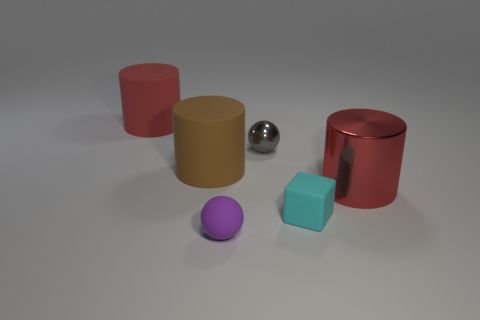There is a metallic thing that is to the right of the cyan cube; is it the same color as the thing that is behind the tiny gray object?
Ensure brevity in your answer.  Yes. Is the material of the big red thing right of the gray metallic ball the same as the large brown object?
Your answer should be very brief. No. What is the material of the block?
Offer a very short reply. Rubber. What is the size of the red object that is on the right side of the tiny cyan rubber block?
Your response must be concise. Large. Are there any other things that have the same color as the tiny metallic object?
Your response must be concise. No. Is there a big matte cylinder in front of the tiny sphere behind the small ball that is in front of the gray shiny sphere?
Provide a short and direct response. Yes. Does the big cylinder behind the small gray object have the same color as the metallic cylinder?
Provide a succinct answer. Yes. What number of spheres are gray shiny things or rubber objects?
Keep it short and to the point. 2. The shiny thing that is to the left of the metallic thing in front of the brown object is what shape?
Provide a succinct answer. Sphere. There is a gray metal sphere that is behind the big rubber cylinder on the right side of the red thing to the left of the red metallic cylinder; what size is it?
Provide a succinct answer. Small. 